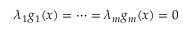<formula> <loc_0><loc_0><loc_500><loc_500>\lambda _ { 1 } g _ { 1 } ( x ) = \cdots = \lambda _ { m } g _ { m } ( x ) = 0</formula> 